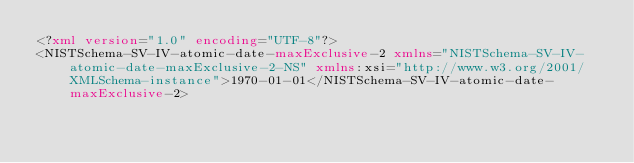Convert code to text. <code><loc_0><loc_0><loc_500><loc_500><_XML_><?xml version="1.0" encoding="UTF-8"?>
<NISTSchema-SV-IV-atomic-date-maxExclusive-2 xmlns="NISTSchema-SV-IV-atomic-date-maxExclusive-2-NS" xmlns:xsi="http://www.w3.org/2001/XMLSchema-instance">1970-01-01</NISTSchema-SV-IV-atomic-date-maxExclusive-2>
</code> 